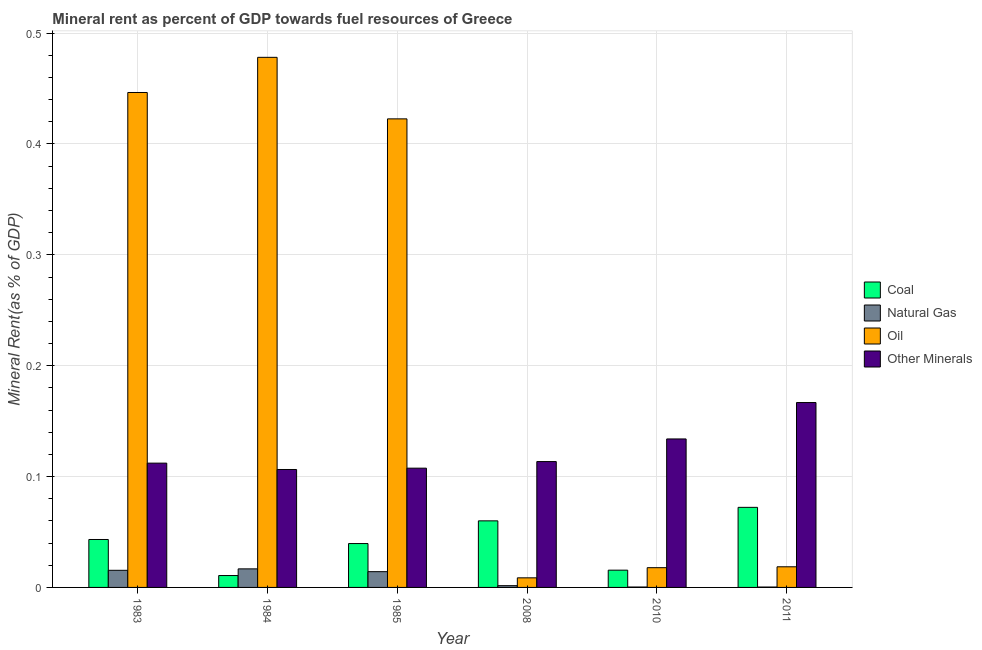Are the number of bars on each tick of the X-axis equal?
Your response must be concise. Yes. How many bars are there on the 4th tick from the left?
Your answer should be very brief. 4. How many bars are there on the 1st tick from the right?
Your answer should be compact. 4. What is the  rent of other minerals in 1983?
Provide a short and direct response. 0.11. Across all years, what is the maximum  rent of other minerals?
Keep it short and to the point. 0.17. Across all years, what is the minimum coal rent?
Offer a terse response. 0.01. In which year was the oil rent maximum?
Provide a succinct answer. 1984. In which year was the  rent of other minerals minimum?
Provide a succinct answer. 1984. What is the total oil rent in the graph?
Ensure brevity in your answer.  1.39. What is the difference between the  rent of other minerals in 1983 and that in 2008?
Offer a very short reply. -0. What is the difference between the coal rent in 2008 and the  rent of other minerals in 1983?
Provide a short and direct response. 0.02. What is the average natural gas rent per year?
Give a very brief answer. 0.01. In how many years, is the  rent of other minerals greater than 0.16 %?
Make the answer very short. 1. What is the ratio of the oil rent in 1983 to that in 2011?
Your response must be concise. 23.98. What is the difference between the highest and the second highest coal rent?
Your answer should be very brief. 0.01. What is the difference between the highest and the lowest natural gas rent?
Your answer should be very brief. 0.02. In how many years, is the coal rent greater than the average coal rent taken over all years?
Your answer should be compact. 3. What does the 2nd bar from the left in 2010 represents?
Offer a very short reply. Natural Gas. What does the 3rd bar from the right in 1984 represents?
Provide a succinct answer. Natural Gas. How many bars are there?
Offer a very short reply. 24. How many years are there in the graph?
Offer a very short reply. 6. What is the difference between two consecutive major ticks on the Y-axis?
Make the answer very short. 0.1. Are the values on the major ticks of Y-axis written in scientific E-notation?
Provide a succinct answer. No. Where does the legend appear in the graph?
Make the answer very short. Center right. How many legend labels are there?
Ensure brevity in your answer.  4. What is the title of the graph?
Keep it short and to the point. Mineral rent as percent of GDP towards fuel resources of Greece. What is the label or title of the X-axis?
Offer a very short reply. Year. What is the label or title of the Y-axis?
Make the answer very short. Mineral Rent(as % of GDP). What is the Mineral Rent(as % of GDP) in Coal in 1983?
Offer a very short reply. 0.04. What is the Mineral Rent(as % of GDP) in Natural Gas in 1983?
Give a very brief answer. 0.02. What is the Mineral Rent(as % of GDP) of Oil in 1983?
Offer a terse response. 0.45. What is the Mineral Rent(as % of GDP) in Other Minerals in 1983?
Provide a short and direct response. 0.11. What is the Mineral Rent(as % of GDP) of Coal in 1984?
Offer a terse response. 0.01. What is the Mineral Rent(as % of GDP) in Natural Gas in 1984?
Give a very brief answer. 0.02. What is the Mineral Rent(as % of GDP) of Oil in 1984?
Your response must be concise. 0.48. What is the Mineral Rent(as % of GDP) in Other Minerals in 1984?
Ensure brevity in your answer.  0.11. What is the Mineral Rent(as % of GDP) of Coal in 1985?
Ensure brevity in your answer.  0.04. What is the Mineral Rent(as % of GDP) of Natural Gas in 1985?
Give a very brief answer. 0.01. What is the Mineral Rent(as % of GDP) in Oil in 1985?
Provide a short and direct response. 0.42. What is the Mineral Rent(as % of GDP) in Other Minerals in 1985?
Ensure brevity in your answer.  0.11. What is the Mineral Rent(as % of GDP) in Coal in 2008?
Offer a very short reply. 0.06. What is the Mineral Rent(as % of GDP) in Natural Gas in 2008?
Offer a terse response. 0. What is the Mineral Rent(as % of GDP) in Oil in 2008?
Keep it short and to the point. 0.01. What is the Mineral Rent(as % of GDP) in Other Minerals in 2008?
Give a very brief answer. 0.11. What is the Mineral Rent(as % of GDP) in Coal in 2010?
Provide a succinct answer. 0.02. What is the Mineral Rent(as % of GDP) of Natural Gas in 2010?
Provide a succinct answer. 0. What is the Mineral Rent(as % of GDP) of Oil in 2010?
Provide a short and direct response. 0.02. What is the Mineral Rent(as % of GDP) of Other Minerals in 2010?
Your response must be concise. 0.13. What is the Mineral Rent(as % of GDP) in Coal in 2011?
Offer a terse response. 0.07. What is the Mineral Rent(as % of GDP) of Natural Gas in 2011?
Offer a terse response. 0. What is the Mineral Rent(as % of GDP) in Oil in 2011?
Your response must be concise. 0.02. What is the Mineral Rent(as % of GDP) of Other Minerals in 2011?
Provide a succinct answer. 0.17. Across all years, what is the maximum Mineral Rent(as % of GDP) in Coal?
Provide a succinct answer. 0.07. Across all years, what is the maximum Mineral Rent(as % of GDP) in Natural Gas?
Ensure brevity in your answer.  0.02. Across all years, what is the maximum Mineral Rent(as % of GDP) in Oil?
Ensure brevity in your answer.  0.48. Across all years, what is the maximum Mineral Rent(as % of GDP) in Other Minerals?
Your answer should be very brief. 0.17. Across all years, what is the minimum Mineral Rent(as % of GDP) in Coal?
Provide a succinct answer. 0.01. Across all years, what is the minimum Mineral Rent(as % of GDP) of Natural Gas?
Make the answer very short. 0. Across all years, what is the minimum Mineral Rent(as % of GDP) in Oil?
Ensure brevity in your answer.  0.01. Across all years, what is the minimum Mineral Rent(as % of GDP) in Other Minerals?
Your answer should be compact. 0.11. What is the total Mineral Rent(as % of GDP) of Coal in the graph?
Offer a terse response. 0.24. What is the total Mineral Rent(as % of GDP) of Natural Gas in the graph?
Give a very brief answer. 0.05. What is the total Mineral Rent(as % of GDP) of Oil in the graph?
Provide a short and direct response. 1.39. What is the total Mineral Rent(as % of GDP) in Other Minerals in the graph?
Your answer should be very brief. 0.74. What is the difference between the Mineral Rent(as % of GDP) of Coal in 1983 and that in 1984?
Make the answer very short. 0.03. What is the difference between the Mineral Rent(as % of GDP) of Natural Gas in 1983 and that in 1984?
Provide a short and direct response. -0. What is the difference between the Mineral Rent(as % of GDP) of Oil in 1983 and that in 1984?
Your answer should be very brief. -0.03. What is the difference between the Mineral Rent(as % of GDP) of Other Minerals in 1983 and that in 1984?
Offer a very short reply. 0.01. What is the difference between the Mineral Rent(as % of GDP) of Coal in 1983 and that in 1985?
Offer a terse response. 0. What is the difference between the Mineral Rent(as % of GDP) of Natural Gas in 1983 and that in 1985?
Your answer should be very brief. 0. What is the difference between the Mineral Rent(as % of GDP) in Oil in 1983 and that in 1985?
Provide a succinct answer. 0.02. What is the difference between the Mineral Rent(as % of GDP) of Other Minerals in 1983 and that in 1985?
Keep it short and to the point. 0. What is the difference between the Mineral Rent(as % of GDP) of Coal in 1983 and that in 2008?
Your response must be concise. -0.02. What is the difference between the Mineral Rent(as % of GDP) in Natural Gas in 1983 and that in 2008?
Provide a succinct answer. 0.01. What is the difference between the Mineral Rent(as % of GDP) in Oil in 1983 and that in 2008?
Your answer should be compact. 0.44. What is the difference between the Mineral Rent(as % of GDP) in Other Minerals in 1983 and that in 2008?
Provide a short and direct response. -0. What is the difference between the Mineral Rent(as % of GDP) of Coal in 1983 and that in 2010?
Provide a succinct answer. 0.03. What is the difference between the Mineral Rent(as % of GDP) of Natural Gas in 1983 and that in 2010?
Provide a succinct answer. 0.02. What is the difference between the Mineral Rent(as % of GDP) in Oil in 1983 and that in 2010?
Offer a terse response. 0.43. What is the difference between the Mineral Rent(as % of GDP) in Other Minerals in 1983 and that in 2010?
Offer a terse response. -0.02. What is the difference between the Mineral Rent(as % of GDP) of Coal in 1983 and that in 2011?
Your answer should be very brief. -0.03. What is the difference between the Mineral Rent(as % of GDP) in Natural Gas in 1983 and that in 2011?
Your response must be concise. 0.02. What is the difference between the Mineral Rent(as % of GDP) in Oil in 1983 and that in 2011?
Provide a short and direct response. 0.43. What is the difference between the Mineral Rent(as % of GDP) in Other Minerals in 1983 and that in 2011?
Keep it short and to the point. -0.05. What is the difference between the Mineral Rent(as % of GDP) of Coal in 1984 and that in 1985?
Offer a very short reply. -0.03. What is the difference between the Mineral Rent(as % of GDP) of Natural Gas in 1984 and that in 1985?
Offer a very short reply. 0. What is the difference between the Mineral Rent(as % of GDP) of Oil in 1984 and that in 1985?
Provide a succinct answer. 0.06. What is the difference between the Mineral Rent(as % of GDP) of Other Minerals in 1984 and that in 1985?
Give a very brief answer. -0. What is the difference between the Mineral Rent(as % of GDP) of Coal in 1984 and that in 2008?
Your answer should be very brief. -0.05. What is the difference between the Mineral Rent(as % of GDP) in Natural Gas in 1984 and that in 2008?
Provide a short and direct response. 0.02. What is the difference between the Mineral Rent(as % of GDP) in Oil in 1984 and that in 2008?
Your response must be concise. 0.47. What is the difference between the Mineral Rent(as % of GDP) in Other Minerals in 1984 and that in 2008?
Give a very brief answer. -0.01. What is the difference between the Mineral Rent(as % of GDP) of Coal in 1984 and that in 2010?
Give a very brief answer. -0. What is the difference between the Mineral Rent(as % of GDP) in Natural Gas in 1984 and that in 2010?
Provide a short and direct response. 0.02. What is the difference between the Mineral Rent(as % of GDP) of Oil in 1984 and that in 2010?
Your response must be concise. 0.46. What is the difference between the Mineral Rent(as % of GDP) of Other Minerals in 1984 and that in 2010?
Provide a succinct answer. -0.03. What is the difference between the Mineral Rent(as % of GDP) of Coal in 1984 and that in 2011?
Your answer should be very brief. -0.06. What is the difference between the Mineral Rent(as % of GDP) in Natural Gas in 1984 and that in 2011?
Your answer should be very brief. 0.02. What is the difference between the Mineral Rent(as % of GDP) in Oil in 1984 and that in 2011?
Provide a short and direct response. 0.46. What is the difference between the Mineral Rent(as % of GDP) in Other Minerals in 1984 and that in 2011?
Your answer should be very brief. -0.06. What is the difference between the Mineral Rent(as % of GDP) of Coal in 1985 and that in 2008?
Provide a short and direct response. -0.02. What is the difference between the Mineral Rent(as % of GDP) of Natural Gas in 1985 and that in 2008?
Keep it short and to the point. 0.01. What is the difference between the Mineral Rent(as % of GDP) in Oil in 1985 and that in 2008?
Your answer should be compact. 0.41. What is the difference between the Mineral Rent(as % of GDP) of Other Minerals in 1985 and that in 2008?
Your response must be concise. -0.01. What is the difference between the Mineral Rent(as % of GDP) of Coal in 1985 and that in 2010?
Ensure brevity in your answer.  0.02. What is the difference between the Mineral Rent(as % of GDP) of Natural Gas in 1985 and that in 2010?
Your answer should be compact. 0.01. What is the difference between the Mineral Rent(as % of GDP) in Oil in 1985 and that in 2010?
Your answer should be very brief. 0.4. What is the difference between the Mineral Rent(as % of GDP) of Other Minerals in 1985 and that in 2010?
Your response must be concise. -0.03. What is the difference between the Mineral Rent(as % of GDP) in Coal in 1985 and that in 2011?
Your response must be concise. -0.03. What is the difference between the Mineral Rent(as % of GDP) in Natural Gas in 1985 and that in 2011?
Provide a succinct answer. 0.01. What is the difference between the Mineral Rent(as % of GDP) of Oil in 1985 and that in 2011?
Keep it short and to the point. 0.4. What is the difference between the Mineral Rent(as % of GDP) in Other Minerals in 1985 and that in 2011?
Offer a very short reply. -0.06. What is the difference between the Mineral Rent(as % of GDP) of Coal in 2008 and that in 2010?
Offer a very short reply. 0.04. What is the difference between the Mineral Rent(as % of GDP) of Natural Gas in 2008 and that in 2010?
Provide a short and direct response. 0. What is the difference between the Mineral Rent(as % of GDP) of Oil in 2008 and that in 2010?
Provide a succinct answer. -0.01. What is the difference between the Mineral Rent(as % of GDP) of Other Minerals in 2008 and that in 2010?
Provide a succinct answer. -0.02. What is the difference between the Mineral Rent(as % of GDP) of Coal in 2008 and that in 2011?
Your answer should be very brief. -0.01. What is the difference between the Mineral Rent(as % of GDP) of Natural Gas in 2008 and that in 2011?
Give a very brief answer. 0. What is the difference between the Mineral Rent(as % of GDP) in Oil in 2008 and that in 2011?
Keep it short and to the point. -0.01. What is the difference between the Mineral Rent(as % of GDP) of Other Minerals in 2008 and that in 2011?
Give a very brief answer. -0.05. What is the difference between the Mineral Rent(as % of GDP) of Coal in 2010 and that in 2011?
Ensure brevity in your answer.  -0.06. What is the difference between the Mineral Rent(as % of GDP) in Natural Gas in 2010 and that in 2011?
Offer a very short reply. 0. What is the difference between the Mineral Rent(as % of GDP) of Oil in 2010 and that in 2011?
Offer a very short reply. -0. What is the difference between the Mineral Rent(as % of GDP) of Other Minerals in 2010 and that in 2011?
Your response must be concise. -0.03. What is the difference between the Mineral Rent(as % of GDP) of Coal in 1983 and the Mineral Rent(as % of GDP) of Natural Gas in 1984?
Make the answer very short. 0.03. What is the difference between the Mineral Rent(as % of GDP) of Coal in 1983 and the Mineral Rent(as % of GDP) of Oil in 1984?
Provide a short and direct response. -0.43. What is the difference between the Mineral Rent(as % of GDP) in Coal in 1983 and the Mineral Rent(as % of GDP) in Other Minerals in 1984?
Make the answer very short. -0.06. What is the difference between the Mineral Rent(as % of GDP) in Natural Gas in 1983 and the Mineral Rent(as % of GDP) in Oil in 1984?
Offer a terse response. -0.46. What is the difference between the Mineral Rent(as % of GDP) in Natural Gas in 1983 and the Mineral Rent(as % of GDP) in Other Minerals in 1984?
Provide a short and direct response. -0.09. What is the difference between the Mineral Rent(as % of GDP) of Oil in 1983 and the Mineral Rent(as % of GDP) of Other Minerals in 1984?
Offer a very short reply. 0.34. What is the difference between the Mineral Rent(as % of GDP) of Coal in 1983 and the Mineral Rent(as % of GDP) of Natural Gas in 1985?
Make the answer very short. 0.03. What is the difference between the Mineral Rent(as % of GDP) in Coal in 1983 and the Mineral Rent(as % of GDP) in Oil in 1985?
Offer a terse response. -0.38. What is the difference between the Mineral Rent(as % of GDP) of Coal in 1983 and the Mineral Rent(as % of GDP) of Other Minerals in 1985?
Your answer should be compact. -0.06. What is the difference between the Mineral Rent(as % of GDP) in Natural Gas in 1983 and the Mineral Rent(as % of GDP) in Oil in 1985?
Give a very brief answer. -0.41. What is the difference between the Mineral Rent(as % of GDP) in Natural Gas in 1983 and the Mineral Rent(as % of GDP) in Other Minerals in 1985?
Make the answer very short. -0.09. What is the difference between the Mineral Rent(as % of GDP) of Oil in 1983 and the Mineral Rent(as % of GDP) of Other Minerals in 1985?
Your answer should be very brief. 0.34. What is the difference between the Mineral Rent(as % of GDP) in Coal in 1983 and the Mineral Rent(as % of GDP) in Natural Gas in 2008?
Offer a terse response. 0.04. What is the difference between the Mineral Rent(as % of GDP) of Coal in 1983 and the Mineral Rent(as % of GDP) of Oil in 2008?
Give a very brief answer. 0.03. What is the difference between the Mineral Rent(as % of GDP) of Coal in 1983 and the Mineral Rent(as % of GDP) of Other Minerals in 2008?
Your answer should be compact. -0.07. What is the difference between the Mineral Rent(as % of GDP) in Natural Gas in 1983 and the Mineral Rent(as % of GDP) in Oil in 2008?
Make the answer very short. 0.01. What is the difference between the Mineral Rent(as % of GDP) in Natural Gas in 1983 and the Mineral Rent(as % of GDP) in Other Minerals in 2008?
Provide a short and direct response. -0.1. What is the difference between the Mineral Rent(as % of GDP) in Oil in 1983 and the Mineral Rent(as % of GDP) in Other Minerals in 2008?
Give a very brief answer. 0.33. What is the difference between the Mineral Rent(as % of GDP) of Coal in 1983 and the Mineral Rent(as % of GDP) of Natural Gas in 2010?
Your response must be concise. 0.04. What is the difference between the Mineral Rent(as % of GDP) in Coal in 1983 and the Mineral Rent(as % of GDP) in Oil in 2010?
Ensure brevity in your answer.  0.03. What is the difference between the Mineral Rent(as % of GDP) of Coal in 1983 and the Mineral Rent(as % of GDP) of Other Minerals in 2010?
Give a very brief answer. -0.09. What is the difference between the Mineral Rent(as % of GDP) of Natural Gas in 1983 and the Mineral Rent(as % of GDP) of Oil in 2010?
Ensure brevity in your answer.  -0. What is the difference between the Mineral Rent(as % of GDP) of Natural Gas in 1983 and the Mineral Rent(as % of GDP) of Other Minerals in 2010?
Give a very brief answer. -0.12. What is the difference between the Mineral Rent(as % of GDP) in Oil in 1983 and the Mineral Rent(as % of GDP) in Other Minerals in 2010?
Offer a very short reply. 0.31. What is the difference between the Mineral Rent(as % of GDP) in Coal in 1983 and the Mineral Rent(as % of GDP) in Natural Gas in 2011?
Make the answer very short. 0.04. What is the difference between the Mineral Rent(as % of GDP) of Coal in 1983 and the Mineral Rent(as % of GDP) of Oil in 2011?
Your response must be concise. 0.02. What is the difference between the Mineral Rent(as % of GDP) in Coal in 1983 and the Mineral Rent(as % of GDP) in Other Minerals in 2011?
Keep it short and to the point. -0.12. What is the difference between the Mineral Rent(as % of GDP) in Natural Gas in 1983 and the Mineral Rent(as % of GDP) in Oil in 2011?
Your answer should be compact. -0. What is the difference between the Mineral Rent(as % of GDP) of Natural Gas in 1983 and the Mineral Rent(as % of GDP) of Other Minerals in 2011?
Your answer should be very brief. -0.15. What is the difference between the Mineral Rent(as % of GDP) of Oil in 1983 and the Mineral Rent(as % of GDP) of Other Minerals in 2011?
Provide a short and direct response. 0.28. What is the difference between the Mineral Rent(as % of GDP) of Coal in 1984 and the Mineral Rent(as % of GDP) of Natural Gas in 1985?
Keep it short and to the point. -0. What is the difference between the Mineral Rent(as % of GDP) of Coal in 1984 and the Mineral Rent(as % of GDP) of Oil in 1985?
Offer a terse response. -0.41. What is the difference between the Mineral Rent(as % of GDP) in Coal in 1984 and the Mineral Rent(as % of GDP) in Other Minerals in 1985?
Provide a succinct answer. -0.1. What is the difference between the Mineral Rent(as % of GDP) in Natural Gas in 1984 and the Mineral Rent(as % of GDP) in Oil in 1985?
Give a very brief answer. -0.41. What is the difference between the Mineral Rent(as % of GDP) of Natural Gas in 1984 and the Mineral Rent(as % of GDP) of Other Minerals in 1985?
Offer a very short reply. -0.09. What is the difference between the Mineral Rent(as % of GDP) in Oil in 1984 and the Mineral Rent(as % of GDP) in Other Minerals in 1985?
Offer a very short reply. 0.37. What is the difference between the Mineral Rent(as % of GDP) of Coal in 1984 and the Mineral Rent(as % of GDP) of Natural Gas in 2008?
Your answer should be very brief. 0.01. What is the difference between the Mineral Rent(as % of GDP) in Coal in 1984 and the Mineral Rent(as % of GDP) in Oil in 2008?
Offer a terse response. 0. What is the difference between the Mineral Rent(as % of GDP) of Coal in 1984 and the Mineral Rent(as % of GDP) of Other Minerals in 2008?
Provide a succinct answer. -0.1. What is the difference between the Mineral Rent(as % of GDP) in Natural Gas in 1984 and the Mineral Rent(as % of GDP) in Oil in 2008?
Offer a very short reply. 0.01. What is the difference between the Mineral Rent(as % of GDP) in Natural Gas in 1984 and the Mineral Rent(as % of GDP) in Other Minerals in 2008?
Provide a short and direct response. -0.1. What is the difference between the Mineral Rent(as % of GDP) of Oil in 1984 and the Mineral Rent(as % of GDP) of Other Minerals in 2008?
Provide a short and direct response. 0.36. What is the difference between the Mineral Rent(as % of GDP) of Coal in 1984 and the Mineral Rent(as % of GDP) of Natural Gas in 2010?
Make the answer very short. 0.01. What is the difference between the Mineral Rent(as % of GDP) in Coal in 1984 and the Mineral Rent(as % of GDP) in Oil in 2010?
Make the answer very short. -0.01. What is the difference between the Mineral Rent(as % of GDP) of Coal in 1984 and the Mineral Rent(as % of GDP) of Other Minerals in 2010?
Your response must be concise. -0.12. What is the difference between the Mineral Rent(as % of GDP) in Natural Gas in 1984 and the Mineral Rent(as % of GDP) in Oil in 2010?
Make the answer very short. -0. What is the difference between the Mineral Rent(as % of GDP) of Natural Gas in 1984 and the Mineral Rent(as % of GDP) of Other Minerals in 2010?
Provide a succinct answer. -0.12. What is the difference between the Mineral Rent(as % of GDP) in Oil in 1984 and the Mineral Rent(as % of GDP) in Other Minerals in 2010?
Make the answer very short. 0.34. What is the difference between the Mineral Rent(as % of GDP) in Coal in 1984 and the Mineral Rent(as % of GDP) in Natural Gas in 2011?
Offer a terse response. 0.01. What is the difference between the Mineral Rent(as % of GDP) of Coal in 1984 and the Mineral Rent(as % of GDP) of Oil in 2011?
Offer a terse response. -0.01. What is the difference between the Mineral Rent(as % of GDP) in Coal in 1984 and the Mineral Rent(as % of GDP) in Other Minerals in 2011?
Offer a very short reply. -0.16. What is the difference between the Mineral Rent(as % of GDP) of Natural Gas in 1984 and the Mineral Rent(as % of GDP) of Oil in 2011?
Your response must be concise. -0. What is the difference between the Mineral Rent(as % of GDP) in Natural Gas in 1984 and the Mineral Rent(as % of GDP) in Other Minerals in 2011?
Provide a short and direct response. -0.15. What is the difference between the Mineral Rent(as % of GDP) in Oil in 1984 and the Mineral Rent(as % of GDP) in Other Minerals in 2011?
Provide a short and direct response. 0.31. What is the difference between the Mineral Rent(as % of GDP) of Coal in 1985 and the Mineral Rent(as % of GDP) of Natural Gas in 2008?
Provide a short and direct response. 0.04. What is the difference between the Mineral Rent(as % of GDP) in Coal in 1985 and the Mineral Rent(as % of GDP) in Oil in 2008?
Your response must be concise. 0.03. What is the difference between the Mineral Rent(as % of GDP) in Coal in 1985 and the Mineral Rent(as % of GDP) in Other Minerals in 2008?
Provide a succinct answer. -0.07. What is the difference between the Mineral Rent(as % of GDP) in Natural Gas in 1985 and the Mineral Rent(as % of GDP) in Oil in 2008?
Provide a succinct answer. 0.01. What is the difference between the Mineral Rent(as % of GDP) in Natural Gas in 1985 and the Mineral Rent(as % of GDP) in Other Minerals in 2008?
Offer a terse response. -0.1. What is the difference between the Mineral Rent(as % of GDP) in Oil in 1985 and the Mineral Rent(as % of GDP) in Other Minerals in 2008?
Offer a very short reply. 0.31. What is the difference between the Mineral Rent(as % of GDP) of Coal in 1985 and the Mineral Rent(as % of GDP) of Natural Gas in 2010?
Give a very brief answer. 0.04. What is the difference between the Mineral Rent(as % of GDP) in Coal in 1985 and the Mineral Rent(as % of GDP) in Oil in 2010?
Provide a short and direct response. 0.02. What is the difference between the Mineral Rent(as % of GDP) in Coal in 1985 and the Mineral Rent(as % of GDP) in Other Minerals in 2010?
Your answer should be compact. -0.09. What is the difference between the Mineral Rent(as % of GDP) of Natural Gas in 1985 and the Mineral Rent(as % of GDP) of Oil in 2010?
Provide a succinct answer. -0. What is the difference between the Mineral Rent(as % of GDP) of Natural Gas in 1985 and the Mineral Rent(as % of GDP) of Other Minerals in 2010?
Offer a terse response. -0.12. What is the difference between the Mineral Rent(as % of GDP) in Oil in 1985 and the Mineral Rent(as % of GDP) in Other Minerals in 2010?
Make the answer very short. 0.29. What is the difference between the Mineral Rent(as % of GDP) in Coal in 1985 and the Mineral Rent(as % of GDP) in Natural Gas in 2011?
Provide a succinct answer. 0.04. What is the difference between the Mineral Rent(as % of GDP) of Coal in 1985 and the Mineral Rent(as % of GDP) of Oil in 2011?
Make the answer very short. 0.02. What is the difference between the Mineral Rent(as % of GDP) of Coal in 1985 and the Mineral Rent(as % of GDP) of Other Minerals in 2011?
Your answer should be compact. -0.13. What is the difference between the Mineral Rent(as % of GDP) of Natural Gas in 1985 and the Mineral Rent(as % of GDP) of Oil in 2011?
Offer a very short reply. -0. What is the difference between the Mineral Rent(as % of GDP) of Natural Gas in 1985 and the Mineral Rent(as % of GDP) of Other Minerals in 2011?
Your response must be concise. -0.15. What is the difference between the Mineral Rent(as % of GDP) of Oil in 1985 and the Mineral Rent(as % of GDP) of Other Minerals in 2011?
Keep it short and to the point. 0.26. What is the difference between the Mineral Rent(as % of GDP) in Coal in 2008 and the Mineral Rent(as % of GDP) in Natural Gas in 2010?
Your answer should be compact. 0.06. What is the difference between the Mineral Rent(as % of GDP) of Coal in 2008 and the Mineral Rent(as % of GDP) of Oil in 2010?
Offer a very short reply. 0.04. What is the difference between the Mineral Rent(as % of GDP) in Coal in 2008 and the Mineral Rent(as % of GDP) in Other Minerals in 2010?
Offer a very short reply. -0.07. What is the difference between the Mineral Rent(as % of GDP) of Natural Gas in 2008 and the Mineral Rent(as % of GDP) of Oil in 2010?
Your answer should be compact. -0.02. What is the difference between the Mineral Rent(as % of GDP) in Natural Gas in 2008 and the Mineral Rent(as % of GDP) in Other Minerals in 2010?
Your answer should be very brief. -0.13. What is the difference between the Mineral Rent(as % of GDP) in Oil in 2008 and the Mineral Rent(as % of GDP) in Other Minerals in 2010?
Give a very brief answer. -0.13. What is the difference between the Mineral Rent(as % of GDP) in Coal in 2008 and the Mineral Rent(as % of GDP) in Natural Gas in 2011?
Your answer should be very brief. 0.06. What is the difference between the Mineral Rent(as % of GDP) of Coal in 2008 and the Mineral Rent(as % of GDP) of Oil in 2011?
Offer a very short reply. 0.04. What is the difference between the Mineral Rent(as % of GDP) of Coal in 2008 and the Mineral Rent(as % of GDP) of Other Minerals in 2011?
Provide a short and direct response. -0.11. What is the difference between the Mineral Rent(as % of GDP) of Natural Gas in 2008 and the Mineral Rent(as % of GDP) of Oil in 2011?
Make the answer very short. -0.02. What is the difference between the Mineral Rent(as % of GDP) of Natural Gas in 2008 and the Mineral Rent(as % of GDP) of Other Minerals in 2011?
Offer a terse response. -0.17. What is the difference between the Mineral Rent(as % of GDP) of Oil in 2008 and the Mineral Rent(as % of GDP) of Other Minerals in 2011?
Your response must be concise. -0.16. What is the difference between the Mineral Rent(as % of GDP) of Coal in 2010 and the Mineral Rent(as % of GDP) of Natural Gas in 2011?
Your answer should be very brief. 0.02. What is the difference between the Mineral Rent(as % of GDP) in Coal in 2010 and the Mineral Rent(as % of GDP) in Oil in 2011?
Ensure brevity in your answer.  -0. What is the difference between the Mineral Rent(as % of GDP) in Coal in 2010 and the Mineral Rent(as % of GDP) in Other Minerals in 2011?
Offer a very short reply. -0.15. What is the difference between the Mineral Rent(as % of GDP) in Natural Gas in 2010 and the Mineral Rent(as % of GDP) in Oil in 2011?
Your answer should be compact. -0.02. What is the difference between the Mineral Rent(as % of GDP) of Natural Gas in 2010 and the Mineral Rent(as % of GDP) of Other Minerals in 2011?
Your response must be concise. -0.17. What is the difference between the Mineral Rent(as % of GDP) in Oil in 2010 and the Mineral Rent(as % of GDP) in Other Minerals in 2011?
Give a very brief answer. -0.15. What is the average Mineral Rent(as % of GDP) in Coal per year?
Provide a short and direct response. 0.04. What is the average Mineral Rent(as % of GDP) in Natural Gas per year?
Keep it short and to the point. 0.01. What is the average Mineral Rent(as % of GDP) of Oil per year?
Make the answer very short. 0.23. What is the average Mineral Rent(as % of GDP) of Other Minerals per year?
Ensure brevity in your answer.  0.12. In the year 1983, what is the difference between the Mineral Rent(as % of GDP) in Coal and Mineral Rent(as % of GDP) in Natural Gas?
Your answer should be compact. 0.03. In the year 1983, what is the difference between the Mineral Rent(as % of GDP) in Coal and Mineral Rent(as % of GDP) in Oil?
Offer a terse response. -0.4. In the year 1983, what is the difference between the Mineral Rent(as % of GDP) of Coal and Mineral Rent(as % of GDP) of Other Minerals?
Make the answer very short. -0.07. In the year 1983, what is the difference between the Mineral Rent(as % of GDP) in Natural Gas and Mineral Rent(as % of GDP) in Oil?
Give a very brief answer. -0.43. In the year 1983, what is the difference between the Mineral Rent(as % of GDP) in Natural Gas and Mineral Rent(as % of GDP) in Other Minerals?
Your answer should be very brief. -0.1. In the year 1983, what is the difference between the Mineral Rent(as % of GDP) in Oil and Mineral Rent(as % of GDP) in Other Minerals?
Make the answer very short. 0.33. In the year 1984, what is the difference between the Mineral Rent(as % of GDP) of Coal and Mineral Rent(as % of GDP) of Natural Gas?
Give a very brief answer. -0.01. In the year 1984, what is the difference between the Mineral Rent(as % of GDP) in Coal and Mineral Rent(as % of GDP) in Oil?
Offer a terse response. -0.47. In the year 1984, what is the difference between the Mineral Rent(as % of GDP) in Coal and Mineral Rent(as % of GDP) in Other Minerals?
Provide a succinct answer. -0.1. In the year 1984, what is the difference between the Mineral Rent(as % of GDP) in Natural Gas and Mineral Rent(as % of GDP) in Oil?
Provide a succinct answer. -0.46. In the year 1984, what is the difference between the Mineral Rent(as % of GDP) of Natural Gas and Mineral Rent(as % of GDP) of Other Minerals?
Your answer should be compact. -0.09. In the year 1984, what is the difference between the Mineral Rent(as % of GDP) of Oil and Mineral Rent(as % of GDP) of Other Minerals?
Offer a very short reply. 0.37. In the year 1985, what is the difference between the Mineral Rent(as % of GDP) in Coal and Mineral Rent(as % of GDP) in Natural Gas?
Give a very brief answer. 0.03. In the year 1985, what is the difference between the Mineral Rent(as % of GDP) in Coal and Mineral Rent(as % of GDP) in Oil?
Keep it short and to the point. -0.38. In the year 1985, what is the difference between the Mineral Rent(as % of GDP) of Coal and Mineral Rent(as % of GDP) of Other Minerals?
Your response must be concise. -0.07. In the year 1985, what is the difference between the Mineral Rent(as % of GDP) of Natural Gas and Mineral Rent(as % of GDP) of Oil?
Keep it short and to the point. -0.41. In the year 1985, what is the difference between the Mineral Rent(as % of GDP) in Natural Gas and Mineral Rent(as % of GDP) in Other Minerals?
Your answer should be compact. -0.09. In the year 1985, what is the difference between the Mineral Rent(as % of GDP) of Oil and Mineral Rent(as % of GDP) of Other Minerals?
Provide a succinct answer. 0.32. In the year 2008, what is the difference between the Mineral Rent(as % of GDP) of Coal and Mineral Rent(as % of GDP) of Natural Gas?
Your response must be concise. 0.06. In the year 2008, what is the difference between the Mineral Rent(as % of GDP) in Coal and Mineral Rent(as % of GDP) in Oil?
Make the answer very short. 0.05. In the year 2008, what is the difference between the Mineral Rent(as % of GDP) in Coal and Mineral Rent(as % of GDP) in Other Minerals?
Your answer should be very brief. -0.05. In the year 2008, what is the difference between the Mineral Rent(as % of GDP) in Natural Gas and Mineral Rent(as % of GDP) in Oil?
Keep it short and to the point. -0.01. In the year 2008, what is the difference between the Mineral Rent(as % of GDP) of Natural Gas and Mineral Rent(as % of GDP) of Other Minerals?
Ensure brevity in your answer.  -0.11. In the year 2008, what is the difference between the Mineral Rent(as % of GDP) in Oil and Mineral Rent(as % of GDP) in Other Minerals?
Your response must be concise. -0.1. In the year 2010, what is the difference between the Mineral Rent(as % of GDP) of Coal and Mineral Rent(as % of GDP) of Natural Gas?
Provide a short and direct response. 0.02. In the year 2010, what is the difference between the Mineral Rent(as % of GDP) in Coal and Mineral Rent(as % of GDP) in Oil?
Offer a very short reply. -0. In the year 2010, what is the difference between the Mineral Rent(as % of GDP) of Coal and Mineral Rent(as % of GDP) of Other Minerals?
Your response must be concise. -0.12. In the year 2010, what is the difference between the Mineral Rent(as % of GDP) in Natural Gas and Mineral Rent(as % of GDP) in Oil?
Your response must be concise. -0.02. In the year 2010, what is the difference between the Mineral Rent(as % of GDP) in Natural Gas and Mineral Rent(as % of GDP) in Other Minerals?
Your answer should be compact. -0.13. In the year 2010, what is the difference between the Mineral Rent(as % of GDP) of Oil and Mineral Rent(as % of GDP) of Other Minerals?
Provide a succinct answer. -0.12. In the year 2011, what is the difference between the Mineral Rent(as % of GDP) of Coal and Mineral Rent(as % of GDP) of Natural Gas?
Your response must be concise. 0.07. In the year 2011, what is the difference between the Mineral Rent(as % of GDP) in Coal and Mineral Rent(as % of GDP) in Oil?
Your response must be concise. 0.05. In the year 2011, what is the difference between the Mineral Rent(as % of GDP) in Coal and Mineral Rent(as % of GDP) in Other Minerals?
Give a very brief answer. -0.09. In the year 2011, what is the difference between the Mineral Rent(as % of GDP) of Natural Gas and Mineral Rent(as % of GDP) of Oil?
Give a very brief answer. -0.02. In the year 2011, what is the difference between the Mineral Rent(as % of GDP) in Natural Gas and Mineral Rent(as % of GDP) in Other Minerals?
Ensure brevity in your answer.  -0.17. In the year 2011, what is the difference between the Mineral Rent(as % of GDP) in Oil and Mineral Rent(as % of GDP) in Other Minerals?
Ensure brevity in your answer.  -0.15. What is the ratio of the Mineral Rent(as % of GDP) in Coal in 1983 to that in 1984?
Provide a short and direct response. 4.03. What is the ratio of the Mineral Rent(as % of GDP) in Natural Gas in 1983 to that in 1984?
Your answer should be compact. 0.92. What is the ratio of the Mineral Rent(as % of GDP) in Oil in 1983 to that in 1984?
Your answer should be very brief. 0.93. What is the ratio of the Mineral Rent(as % of GDP) in Other Minerals in 1983 to that in 1984?
Make the answer very short. 1.05. What is the ratio of the Mineral Rent(as % of GDP) in Coal in 1983 to that in 1985?
Provide a short and direct response. 1.09. What is the ratio of the Mineral Rent(as % of GDP) in Natural Gas in 1983 to that in 1985?
Offer a terse response. 1.09. What is the ratio of the Mineral Rent(as % of GDP) in Oil in 1983 to that in 1985?
Offer a terse response. 1.06. What is the ratio of the Mineral Rent(as % of GDP) in Other Minerals in 1983 to that in 1985?
Your response must be concise. 1.04. What is the ratio of the Mineral Rent(as % of GDP) in Coal in 1983 to that in 2008?
Ensure brevity in your answer.  0.72. What is the ratio of the Mineral Rent(as % of GDP) in Natural Gas in 1983 to that in 2008?
Your response must be concise. 9.75. What is the ratio of the Mineral Rent(as % of GDP) of Oil in 1983 to that in 2008?
Make the answer very short. 51.59. What is the ratio of the Mineral Rent(as % of GDP) in Coal in 1983 to that in 2010?
Your answer should be compact. 2.78. What is the ratio of the Mineral Rent(as % of GDP) of Natural Gas in 1983 to that in 2010?
Your answer should be compact. 41.68. What is the ratio of the Mineral Rent(as % of GDP) in Oil in 1983 to that in 2010?
Make the answer very short. 25.06. What is the ratio of the Mineral Rent(as % of GDP) in Other Minerals in 1983 to that in 2010?
Make the answer very short. 0.84. What is the ratio of the Mineral Rent(as % of GDP) of Coal in 1983 to that in 2011?
Ensure brevity in your answer.  0.6. What is the ratio of the Mineral Rent(as % of GDP) of Natural Gas in 1983 to that in 2011?
Offer a very short reply. 43.84. What is the ratio of the Mineral Rent(as % of GDP) of Oil in 1983 to that in 2011?
Offer a terse response. 23.98. What is the ratio of the Mineral Rent(as % of GDP) of Other Minerals in 1983 to that in 2011?
Provide a short and direct response. 0.67. What is the ratio of the Mineral Rent(as % of GDP) in Coal in 1984 to that in 1985?
Your answer should be very brief. 0.27. What is the ratio of the Mineral Rent(as % of GDP) of Natural Gas in 1984 to that in 1985?
Your answer should be compact. 1.18. What is the ratio of the Mineral Rent(as % of GDP) of Oil in 1984 to that in 1985?
Keep it short and to the point. 1.13. What is the ratio of the Mineral Rent(as % of GDP) in Other Minerals in 1984 to that in 1985?
Give a very brief answer. 0.99. What is the ratio of the Mineral Rent(as % of GDP) of Coal in 1984 to that in 2008?
Provide a short and direct response. 0.18. What is the ratio of the Mineral Rent(as % of GDP) of Natural Gas in 1984 to that in 2008?
Ensure brevity in your answer.  10.57. What is the ratio of the Mineral Rent(as % of GDP) in Oil in 1984 to that in 2008?
Your answer should be very brief. 55.26. What is the ratio of the Mineral Rent(as % of GDP) in Other Minerals in 1984 to that in 2008?
Your answer should be compact. 0.94. What is the ratio of the Mineral Rent(as % of GDP) of Coal in 1984 to that in 2010?
Your response must be concise. 0.69. What is the ratio of the Mineral Rent(as % of GDP) in Natural Gas in 1984 to that in 2010?
Ensure brevity in your answer.  45.2. What is the ratio of the Mineral Rent(as % of GDP) of Oil in 1984 to that in 2010?
Offer a terse response. 26.84. What is the ratio of the Mineral Rent(as % of GDP) of Other Minerals in 1984 to that in 2010?
Your answer should be compact. 0.79. What is the ratio of the Mineral Rent(as % of GDP) of Coal in 1984 to that in 2011?
Give a very brief answer. 0.15. What is the ratio of the Mineral Rent(as % of GDP) in Natural Gas in 1984 to that in 2011?
Provide a succinct answer. 47.54. What is the ratio of the Mineral Rent(as % of GDP) of Oil in 1984 to that in 2011?
Your response must be concise. 25.68. What is the ratio of the Mineral Rent(as % of GDP) in Other Minerals in 1984 to that in 2011?
Offer a terse response. 0.64. What is the ratio of the Mineral Rent(as % of GDP) in Coal in 1985 to that in 2008?
Ensure brevity in your answer.  0.66. What is the ratio of the Mineral Rent(as % of GDP) in Natural Gas in 1985 to that in 2008?
Your response must be concise. 8.97. What is the ratio of the Mineral Rent(as % of GDP) of Oil in 1985 to that in 2008?
Provide a short and direct response. 48.84. What is the ratio of the Mineral Rent(as % of GDP) in Other Minerals in 1985 to that in 2008?
Provide a succinct answer. 0.95. What is the ratio of the Mineral Rent(as % of GDP) of Coal in 1985 to that in 2010?
Ensure brevity in your answer.  2.54. What is the ratio of the Mineral Rent(as % of GDP) of Natural Gas in 1985 to that in 2010?
Give a very brief answer. 38.38. What is the ratio of the Mineral Rent(as % of GDP) in Oil in 1985 to that in 2010?
Your response must be concise. 23.73. What is the ratio of the Mineral Rent(as % of GDP) of Other Minerals in 1985 to that in 2010?
Ensure brevity in your answer.  0.8. What is the ratio of the Mineral Rent(as % of GDP) in Coal in 1985 to that in 2011?
Provide a succinct answer. 0.55. What is the ratio of the Mineral Rent(as % of GDP) of Natural Gas in 1985 to that in 2011?
Your response must be concise. 40.38. What is the ratio of the Mineral Rent(as % of GDP) in Oil in 1985 to that in 2011?
Your answer should be compact. 22.7. What is the ratio of the Mineral Rent(as % of GDP) in Other Minerals in 1985 to that in 2011?
Your response must be concise. 0.65. What is the ratio of the Mineral Rent(as % of GDP) of Coal in 2008 to that in 2010?
Give a very brief answer. 3.86. What is the ratio of the Mineral Rent(as % of GDP) of Natural Gas in 2008 to that in 2010?
Your response must be concise. 4.28. What is the ratio of the Mineral Rent(as % of GDP) of Oil in 2008 to that in 2010?
Provide a short and direct response. 0.49. What is the ratio of the Mineral Rent(as % of GDP) in Other Minerals in 2008 to that in 2010?
Provide a short and direct response. 0.85. What is the ratio of the Mineral Rent(as % of GDP) in Coal in 2008 to that in 2011?
Offer a terse response. 0.83. What is the ratio of the Mineral Rent(as % of GDP) in Natural Gas in 2008 to that in 2011?
Provide a short and direct response. 4.5. What is the ratio of the Mineral Rent(as % of GDP) in Oil in 2008 to that in 2011?
Keep it short and to the point. 0.46. What is the ratio of the Mineral Rent(as % of GDP) of Other Minerals in 2008 to that in 2011?
Ensure brevity in your answer.  0.68. What is the ratio of the Mineral Rent(as % of GDP) in Coal in 2010 to that in 2011?
Offer a terse response. 0.22. What is the ratio of the Mineral Rent(as % of GDP) of Natural Gas in 2010 to that in 2011?
Provide a succinct answer. 1.05. What is the ratio of the Mineral Rent(as % of GDP) in Oil in 2010 to that in 2011?
Provide a succinct answer. 0.96. What is the ratio of the Mineral Rent(as % of GDP) in Other Minerals in 2010 to that in 2011?
Your answer should be compact. 0.8. What is the difference between the highest and the second highest Mineral Rent(as % of GDP) in Coal?
Offer a very short reply. 0.01. What is the difference between the highest and the second highest Mineral Rent(as % of GDP) in Natural Gas?
Ensure brevity in your answer.  0. What is the difference between the highest and the second highest Mineral Rent(as % of GDP) of Oil?
Offer a very short reply. 0.03. What is the difference between the highest and the second highest Mineral Rent(as % of GDP) in Other Minerals?
Give a very brief answer. 0.03. What is the difference between the highest and the lowest Mineral Rent(as % of GDP) in Coal?
Your answer should be compact. 0.06. What is the difference between the highest and the lowest Mineral Rent(as % of GDP) in Natural Gas?
Ensure brevity in your answer.  0.02. What is the difference between the highest and the lowest Mineral Rent(as % of GDP) in Oil?
Provide a succinct answer. 0.47. What is the difference between the highest and the lowest Mineral Rent(as % of GDP) of Other Minerals?
Offer a very short reply. 0.06. 